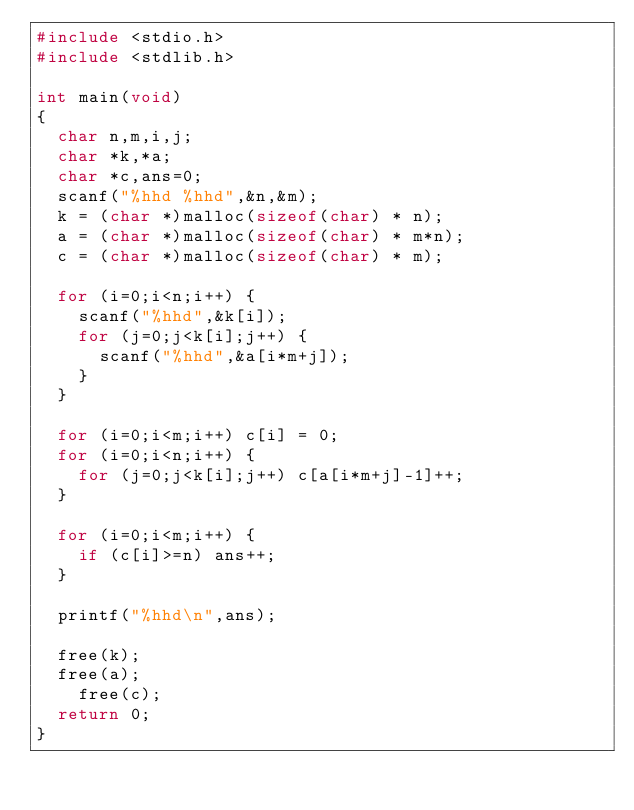Convert code to text. <code><loc_0><loc_0><loc_500><loc_500><_C_>#include <stdio.h>
#include <stdlib.h>

int main(void)
{
	char n,m,i,j;
	char *k,*a;
	char *c,ans=0;
	scanf("%hhd %hhd",&n,&m);
	k = (char *)malloc(sizeof(char) * n);
	a = (char *)malloc(sizeof(char) * m*n);
	c = (char *)malloc(sizeof(char) * m);
	
	for (i=0;i<n;i++) {
		scanf("%hhd",&k[i]);
		for (j=0;j<k[i];j++) {
			scanf("%hhd",&a[i*m+j]);
		}
	}
	
	for (i=0;i<m;i++) c[i] = 0;
	for (i=0;i<n;i++) {
		for (j=0;j<k[i];j++) c[a[i*m+j]-1]++;
	}

	for (i=0;i<m;i++) {
		if (c[i]>=n) ans++;
	}

	printf("%hhd\n",ans);

	free(k);
	free(a);
  	free(c);
	return 0;
}</code> 